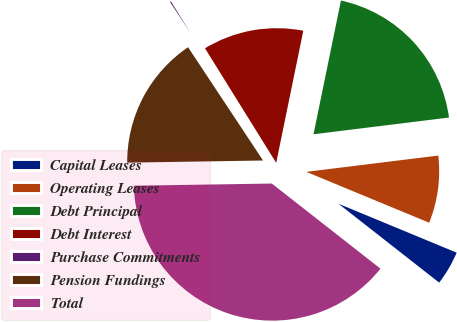<chart> <loc_0><loc_0><loc_500><loc_500><pie_chart><fcel>Capital Leases<fcel>Operating Leases<fcel>Debt Principal<fcel>Debt Interest<fcel>Purchase Commitments<fcel>Pension Fundings<fcel>Total<nl><fcel>4.33%<fcel>8.2%<fcel>19.82%<fcel>12.07%<fcel>0.46%<fcel>15.94%<fcel>39.17%<nl></chart> 